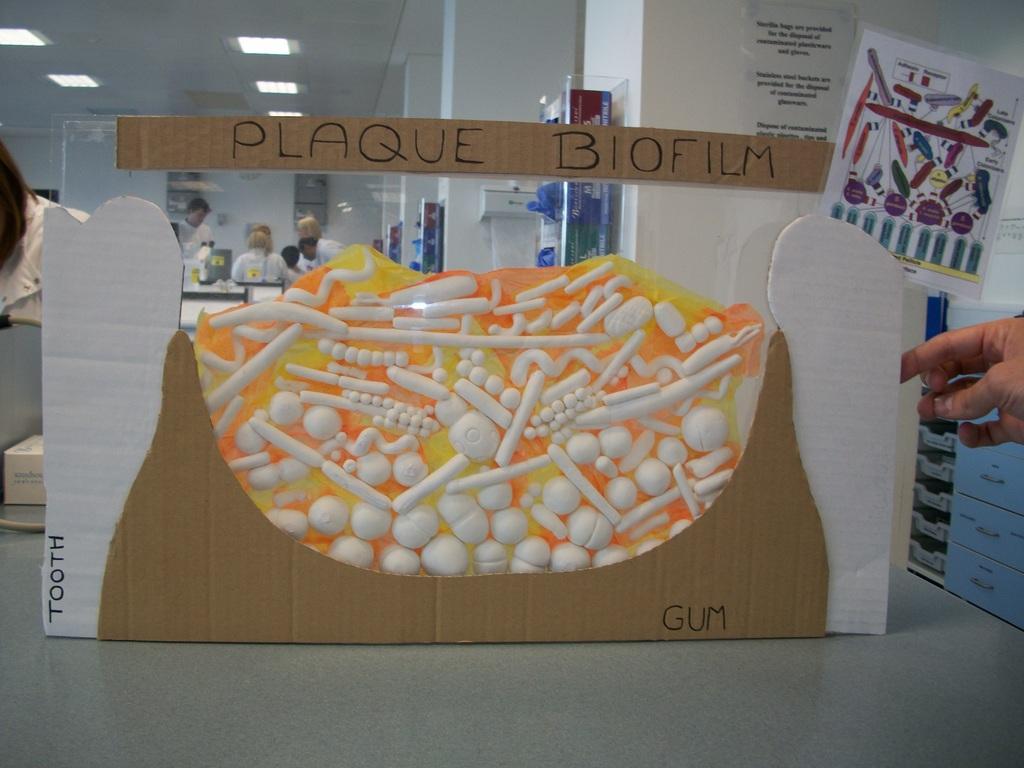Can you describe this image briefly? In this picture, we see a glass board and a cardboard with some text written on it. Beside that, we see a chart and behind that, we see a pillar on which a poster is pasted. Behind that, we see the pillars and the boxes in white, blue and red color. We see the people are standing. On the left side, we see a woman is standing. On the right side, we see the hands of the person and the drawers in blue color. At the top, we see the ceiling of the room. 